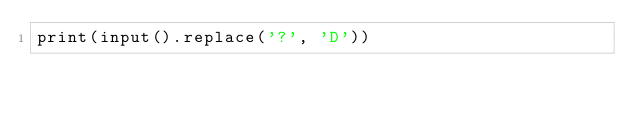<code> <loc_0><loc_0><loc_500><loc_500><_Python_>print(input().replace('?', 'D'))</code> 